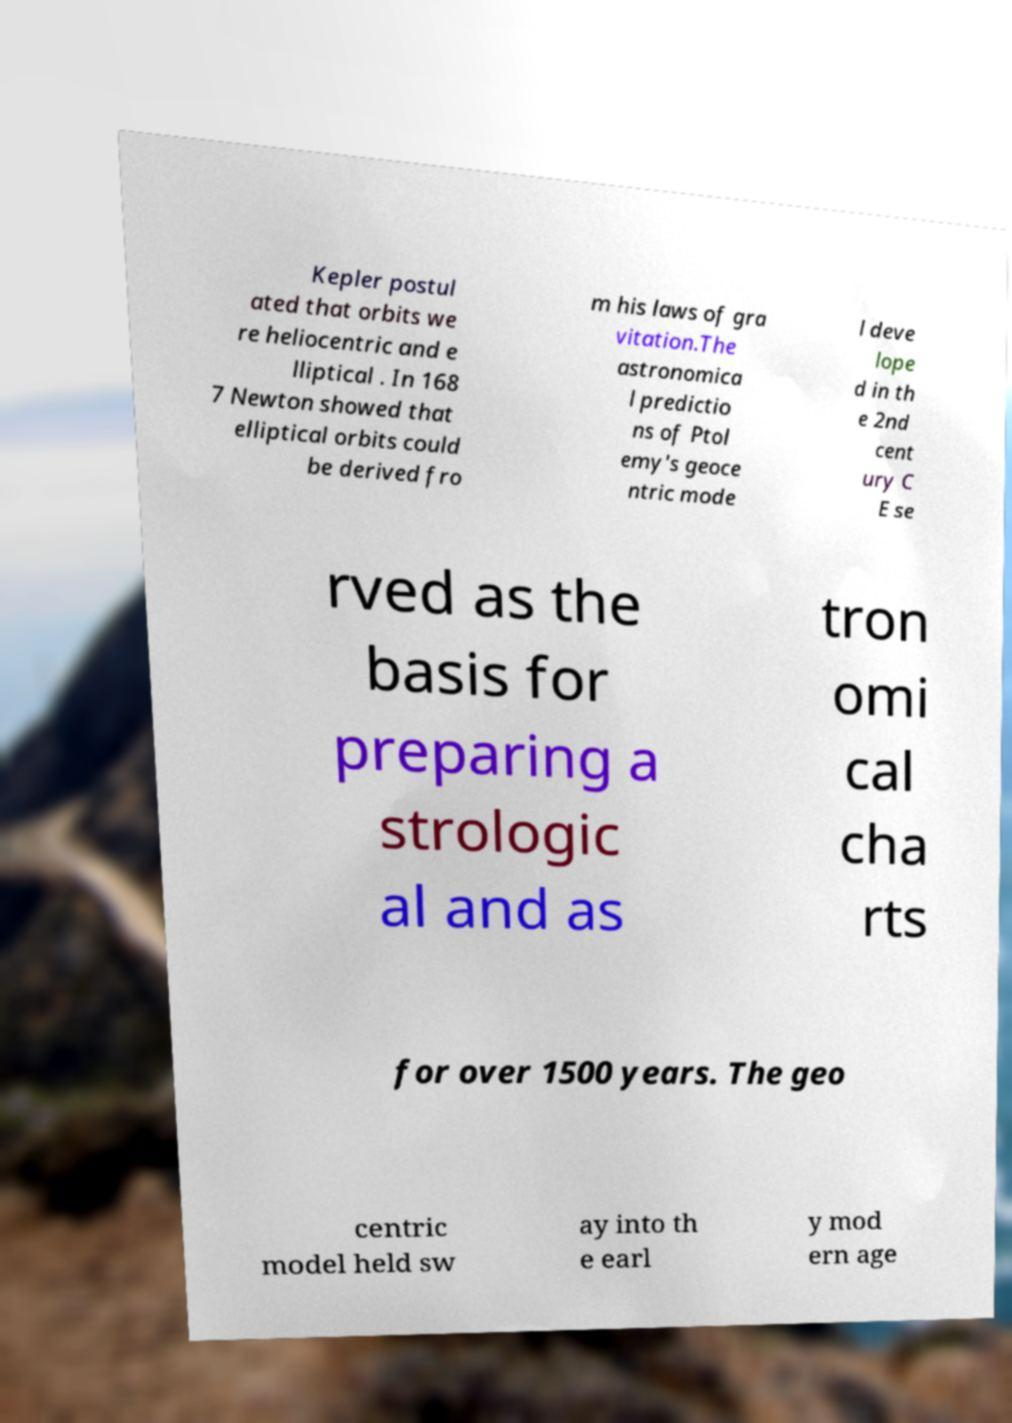There's text embedded in this image that I need extracted. Can you transcribe it verbatim? Kepler postul ated that orbits we re heliocentric and e lliptical . In 168 7 Newton showed that elliptical orbits could be derived fro m his laws of gra vitation.The astronomica l predictio ns of Ptol emy's geoce ntric mode l deve lope d in th e 2nd cent ury C E se rved as the basis for preparing a strologic al and as tron omi cal cha rts for over 1500 years. The geo centric model held sw ay into th e earl y mod ern age 